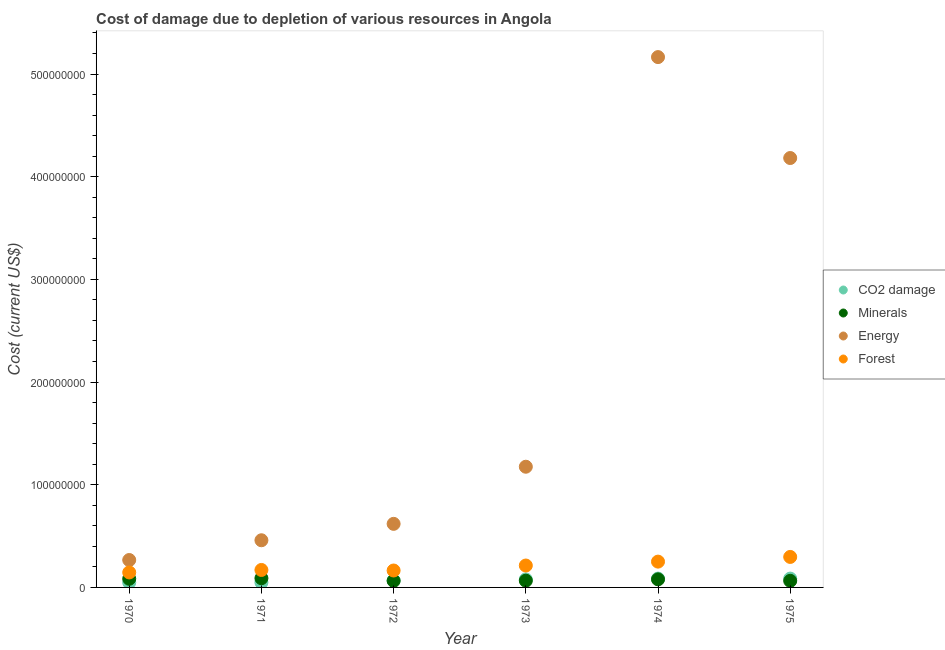What is the cost of damage due to depletion of coal in 1975?
Give a very brief answer. 8.60e+06. Across all years, what is the maximum cost of damage due to depletion of coal?
Offer a terse response. 8.60e+06. Across all years, what is the minimum cost of damage due to depletion of minerals?
Give a very brief answer. 6.41e+06. In which year was the cost of damage due to depletion of energy maximum?
Your response must be concise. 1974. What is the total cost of damage due to depletion of coal in the graph?
Your response must be concise. 4.14e+07. What is the difference between the cost of damage due to depletion of forests in 1971 and that in 1975?
Give a very brief answer. -1.27e+07. What is the difference between the cost of damage due to depletion of minerals in 1972 and the cost of damage due to depletion of coal in 1971?
Ensure brevity in your answer.  1.59e+06. What is the average cost of damage due to depletion of minerals per year?
Your response must be concise. 7.45e+06. In the year 1973, what is the difference between the cost of damage due to depletion of minerals and cost of damage due to depletion of forests?
Offer a terse response. -1.48e+07. What is the ratio of the cost of damage due to depletion of forests in 1973 to that in 1974?
Make the answer very short. 0.85. What is the difference between the highest and the second highest cost of damage due to depletion of coal?
Provide a succinct answer. 1.27e+04. What is the difference between the highest and the lowest cost of damage due to depletion of forests?
Your answer should be very brief. 1.51e+07. In how many years, is the cost of damage due to depletion of energy greater than the average cost of damage due to depletion of energy taken over all years?
Offer a very short reply. 2. Is the sum of the cost of damage due to depletion of forests in 1972 and 1974 greater than the maximum cost of damage due to depletion of coal across all years?
Keep it short and to the point. Yes. Is it the case that in every year, the sum of the cost of damage due to depletion of energy and cost of damage due to depletion of forests is greater than the sum of cost of damage due to depletion of minerals and cost of damage due to depletion of coal?
Your answer should be compact. Yes. Is the cost of damage due to depletion of minerals strictly less than the cost of damage due to depletion of coal over the years?
Your answer should be compact. No. How many dotlines are there?
Your response must be concise. 4. Are the values on the major ticks of Y-axis written in scientific E-notation?
Make the answer very short. No. Does the graph contain any zero values?
Keep it short and to the point. No. Does the graph contain grids?
Offer a terse response. No. Where does the legend appear in the graph?
Offer a terse response. Center right. How many legend labels are there?
Keep it short and to the point. 4. How are the legend labels stacked?
Offer a terse response. Vertical. What is the title of the graph?
Make the answer very short. Cost of damage due to depletion of various resources in Angola . Does "Other expenses" appear as one of the legend labels in the graph?
Ensure brevity in your answer.  No. What is the label or title of the Y-axis?
Your response must be concise. Cost (current US$). What is the Cost (current US$) of CO2 damage in 1970?
Your answer should be compact. 4.78e+06. What is the Cost (current US$) in Minerals in 1970?
Provide a short and direct response. 8.42e+06. What is the Cost (current US$) of Energy in 1970?
Offer a terse response. 2.67e+07. What is the Cost (current US$) in Forest in 1970?
Provide a succinct answer. 1.46e+07. What is the Cost (current US$) in CO2 damage in 1971?
Offer a very short reply. 4.84e+06. What is the Cost (current US$) of Minerals in 1971?
Provide a succinct answer. 8.98e+06. What is the Cost (current US$) in Energy in 1971?
Provide a short and direct response. 4.59e+07. What is the Cost (current US$) of Forest in 1971?
Ensure brevity in your answer.  1.70e+07. What is the Cost (current US$) in CO2 damage in 1972?
Offer a very short reply. 6.75e+06. What is the Cost (current US$) in Minerals in 1972?
Offer a very short reply. 6.43e+06. What is the Cost (current US$) in Energy in 1972?
Ensure brevity in your answer.  6.19e+07. What is the Cost (current US$) in Forest in 1972?
Offer a very short reply. 1.65e+07. What is the Cost (current US$) in CO2 damage in 1973?
Keep it short and to the point. 7.80e+06. What is the Cost (current US$) in Minerals in 1973?
Your answer should be compact. 6.57e+06. What is the Cost (current US$) in Energy in 1973?
Offer a very short reply. 1.18e+08. What is the Cost (current US$) of Forest in 1973?
Provide a succinct answer. 2.13e+07. What is the Cost (current US$) of CO2 damage in 1974?
Keep it short and to the point. 8.59e+06. What is the Cost (current US$) in Minerals in 1974?
Provide a short and direct response. 7.87e+06. What is the Cost (current US$) in Energy in 1974?
Make the answer very short. 5.16e+08. What is the Cost (current US$) in Forest in 1974?
Keep it short and to the point. 2.51e+07. What is the Cost (current US$) of CO2 damage in 1975?
Give a very brief answer. 8.60e+06. What is the Cost (current US$) in Minerals in 1975?
Provide a short and direct response. 6.41e+06. What is the Cost (current US$) of Energy in 1975?
Your response must be concise. 4.18e+08. What is the Cost (current US$) in Forest in 1975?
Provide a short and direct response. 2.97e+07. Across all years, what is the maximum Cost (current US$) of CO2 damage?
Give a very brief answer. 8.60e+06. Across all years, what is the maximum Cost (current US$) of Minerals?
Offer a terse response. 8.98e+06. Across all years, what is the maximum Cost (current US$) in Energy?
Provide a short and direct response. 5.16e+08. Across all years, what is the maximum Cost (current US$) of Forest?
Offer a very short reply. 2.97e+07. Across all years, what is the minimum Cost (current US$) of CO2 damage?
Ensure brevity in your answer.  4.78e+06. Across all years, what is the minimum Cost (current US$) in Minerals?
Your answer should be compact. 6.41e+06. Across all years, what is the minimum Cost (current US$) of Energy?
Your answer should be compact. 2.67e+07. Across all years, what is the minimum Cost (current US$) in Forest?
Offer a very short reply. 1.46e+07. What is the total Cost (current US$) of CO2 damage in the graph?
Provide a short and direct response. 4.14e+07. What is the total Cost (current US$) of Minerals in the graph?
Keep it short and to the point. 4.47e+07. What is the total Cost (current US$) in Energy in the graph?
Your answer should be compact. 1.19e+09. What is the total Cost (current US$) of Forest in the graph?
Make the answer very short. 1.24e+08. What is the difference between the Cost (current US$) in CO2 damage in 1970 and that in 1971?
Offer a terse response. -5.73e+04. What is the difference between the Cost (current US$) of Minerals in 1970 and that in 1971?
Your answer should be compact. -5.59e+05. What is the difference between the Cost (current US$) of Energy in 1970 and that in 1971?
Make the answer very short. -1.92e+07. What is the difference between the Cost (current US$) of Forest in 1970 and that in 1971?
Your response must be concise. -2.42e+06. What is the difference between the Cost (current US$) of CO2 damage in 1970 and that in 1972?
Make the answer very short. -1.97e+06. What is the difference between the Cost (current US$) of Minerals in 1970 and that in 1972?
Your answer should be compact. 1.99e+06. What is the difference between the Cost (current US$) in Energy in 1970 and that in 1972?
Keep it short and to the point. -3.52e+07. What is the difference between the Cost (current US$) in Forest in 1970 and that in 1972?
Give a very brief answer. -1.89e+06. What is the difference between the Cost (current US$) of CO2 damage in 1970 and that in 1973?
Make the answer very short. -3.02e+06. What is the difference between the Cost (current US$) in Minerals in 1970 and that in 1973?
Your answer should be very brief. 1.85e+06. What is the difference between the Cost (current US$) of Energy in 1970 and that in 1973?
Your response must be concise. -9.08e+07. What is the difference between the Cost (current US$) in Forest in 1970 and that in 1973?
Provide a short and direct response. -6.74e+06. What is the difference between the Cost (current US$) in CO2 damage in 1970 and that in 1974?
Provide a short and direct response. -3.80e+06. What is the difference between the Cost (current US$) in Minerals in 1970 and that in 1974?
Your answer should be compact. 5.56e+05. What is the difference between the Cost (current US$) of Energy in 1970 and that in 1974?
Provide a short and direct response. -4.90e+08. What is the difference between the Cost (current US$) of Forest in 1970 and that in 1974?
Your response must be concise. -1.05e+07. What is the difference between the Cost (current US$) in CO2 damage in 1970 and that in 1975?
Your answer should be compact. -3.82e+06. What is the difference between the Cost (current US$) in Minerals in 1970 and that in 1975?
Offer a very short reply. 2.01e+06. What is the difference between the Cost (current US$) of Energy in 1970 and that in 1975?
Your answer should be compact. -3.91e+08. What is the difference between the Cost (current US$) in Forest in 1970 and that in 1975?
Provide a short and direct response. -1.51e+07. What is the difference between the Cost (current US$) of CO2 damage in 1971 and that in 1972?
Offer a very short reply. -1.91e+06. What is the difference between the Cost (current US$) in Minerals in 1971 and that in 1972?
Your answer should be very brief. 2.55e+06. What is the difference between the Cost (current US$) in Energy in 1971 and that in 1972?
Provide a succinct answer. -1.60e+07. What is the difference between the Cost (current US$) in Forest in 1971 and that in 1972?
Offer a very short reply. 5.24e+05. What is the difference between the Cost (current US$) in CO2 damage in 1971 and that in 1973?
Give a very brief answer. -2.96e+06. What is the difference between the Cost (current US$) in Minerals in 1971 and that in 1973?
Provide a short and direct response. 2.41e+06. What is the difference between the Cost (current US$) of Energy in 1971 and that in 1973?
Make the answer very short. -7.16e+07. What is the difference between the Cost (current US$) in Forest in 1971 and that in 1973?
Give a very brief answer. -4.33e+06. What is the difference between the Cost (current US$) in CO2 damage in 1971 and that in 1974?
Offer a very short reply. -3.75e+06. What is the difference between the Cost (current US$) in Minerals in 1971 and that in 1974?
Make the answer very short. 1.12e+06. What is the difference between the Cost (current US$) in Energy in 1971 and that in 1974?
Ensure brevity in your answer.  -4.71e+08. What is the difference between the Cost (current US$) of Forest in 1971 and that in 1974?
Your answer should be very brief. -8.12e+06. What is the difference between the Cost (current US$) of CO2 damage in 1971 and that in 1975?
Give a very brief answer. -3.76e+06. What is the difference between the Cost (current US$) of Minerals in 1971 and that in 1975?
Your answer should be very brief. 2.57e+06. What is the difference between the Cost (current US$) in Energy in 1971 and that in 1975?
Offer a terse response. -3.72e+08. What is the difference between the Cost (current US$) of Forest in 1971 and that in 1975?
Ensure brevity in your answer.  -1.27e+07. What is the difference between the Cost (current US$) in CO2 damage in 1972 and that in 1973?
Keep it short and to the point. -1.05e+06. What is the difference between the Cost (current US$) of Minerals in 1972 and that in 1973?
Make the answer very short. -1.45e+05. What is the difference between the Cost (current US$) of Energy in 1972 and that in 1973?
Your answer should be compact. -5.56e+07. What is the difference between the Cost (current US$) in Forest in 1972 and that in 1973?
Your answer should be compact. -4.85e+06. What is the difference between the Cost (current US$) in CO2 damage in 1972 and that in 1974?
Ensure brevity in your answer.  -1.84e+06. What is the difference between the Cost (current US$) in Minerals in 1972 and that in 1974?
Your answer should be very brief. -1.44e+06. What is the difference between the Cost (current US$) of Energy in 1972 and that in 1974?
Your answer should be very brief. -4.55e+08. What is the difference between the Cost (current US$) of Forest in 1972 and that in 1974?
Keep it short and to the point. -8.65e+06. What is the difference between the Cost (current US$) of CO2 damage in 1972 and that in 1975?
Your response must be concise. -1.85e+06. What is the difference between the Cost (current US$) in Minerals in 1972 and that in 1975?
Your answer should be compact. 1.51e+04. What is the difference between the Cost (current US$) of Energy in 1972 and that in 1975?
Ensure brevity in your answer.  -3.56e+08. What is the difference between the Cost (current US$) in Forest in 1972 and that in 1975?
Your answer should be very brief. -1.32e+07. What is the difference between the Cost (current US$) in CO2 damage in 1973 and that in 1974?
Your response must be concise. -7.88e+05. What is the difference between the Cost (current US$) of Minerals in 1973 and that in 1974?
Your answer should be very brief. -1.29e+06. What is the difference between the Cost (current US$) of Energy in 1973 and that in 1974?
Give a very brief answer. -3.99e+08. What is the difference between the Cost (current US$) in Forest in 1973 and that in 1974?
Keep it short and to the point. -3.80e+06. What is the difference between the Cost (current US$) of CO2 damage in 1973 and that in 1975?
Make the answer very short. -8.00e+05. What is the difference between the Cost (current US$) of Minerals in 1973 and that in 1975?
Your response must be concise. 1.60e+05. What is the difference between the Cost (current US$) of Energy in 1973 and that in 1975?
Your answer should be very brief. -3.01e+08. What is the difference between the Cost (current US$) in Forest in 1973 and that in 1975?
Provide a succinct answer. -8.37e+06. What is the difference between the Cost (current US$) of CO2 damage in 1974 and that in 1975?
Make the answer very short. -1.27e+04. What is the difference between the Cost (current US$) in Minerals in 1974 and that in 1975?
Offer a terse response. 1.45e+06. What is the difference between the Cost (current US$) of Energy in 1974 and that in 1975?
Your answer should be very brief. 9.83e+07. What is the difference between the Cost (current US$) in Forest in 1974 and that in 1975?
Provide a short and direct response. -4.57e+06. What is the difference between the Cost (current US$) of CO2 damage in 1970 and the Cost (current US$) of Minerals in 1971?
Give a very brief answer. -4.20e+06. What is the difference between the Cost (current US$) of CO2 damage in 1970 and the Cost (current US$) of Energy in 1971?
Give a very brief answer. -4.11e+07. What is the difference between the Cost (current US$) in CO2 damage in 1970 and the Cost (current US$) in Forest in 1971?
Make the answer very short. -1.22e+07. What is the difference between the Cost (current US$) in Minerals in 1970 and the Cost (current US$) in Energy in 1971?
Make the answer very short. -3.75e+07. What is the difference between the Cost (current US$) of Minerals in 1970 and the Cost (current US$) of Forest in 1971?
Give a very brief answer. -8.58e+06. What is the difference between the Cost (current US$) in Energy in 1970 and the Cost (current US$) in Forest in 1971?
Keep it short and to the point. 9.69e+06. What is the difference between the Cost (current US$) of CO2 damage in 1970 and the Cost (current US$) of Minerals in 1972?
Your response must be concise. -1.65e+06. What is the difference between the Cost (current US$) in CO2 damage in 1970 and the Cost (current US$) in Energy in 1972?
Provide a succinct answer. -5.71e+07. What is the difference between the Cost (current US$) in CO2 damage in 1970 and the Cost (current US$) in Forest in 1972?
Your response must be concise. -1.17e+07. What is the difference between the Cost (current US$) in Minerals in 1970 and the Cost (current US$) in Energy in 1972?
Provide a succinct answer. -5.35e+07. What is the difference between the Cost (current US$) of Minerals in 1970 and the Cost (current US$) of Forest in 1972?
Ensure brevity in your answer.  -8.06e+06. What is the difference between the Cost (current US$) of Energy in 1970 and the Cost (current US$) of Forest in 1972?
Your answer should be compact. 1.02e+07. What is the difference between the Cost (current US$) in CO2 damage in 1970 and the Cost (current US$) in Minerals in 1973?
Offer a terse response. -1.79e+06. What is the difference between the Cost (current US$) of CO2 damage in 1970 and the Cost (current US$) of Energy in 1973?
Give a very brief answer. -1.13e+08. What is the difference between the Cost (current US$) of CO2 damage in 1970 and the Cost (current US$) of Forest in 1973?
Keep it short and to the point. -1.65e+07. What is the difference between the Cost (current US$) of Minerals in 1970 and the Cost (current US$) of Energy in 1973?
Give a very brief answer. -1.09e+08. What is the difference between the Cost (current US$) in Minerals in 1970 and the Cost (current US$) in Forest in 1973?
Ensure brevity in your answer.  -1.29e+07. What is the difference between the Cost (current US$) of Energy in 1970 and the Cost (current US$) of Forest in 1973?
Provide a succinct answer. 5.37e+06. What is the difference between the Cost (current US$) of CO2 damage in 1970 and the Cost (current US$) of Minerals in 1974?
Provide a succinct answer. -3.08e+06. What is the difference between the Cost (current US$) of CO2 damage in 1970 and the Cost (current US$) of Energy in 1974?
Provide a succinct answer. -5.12e+08. What is the difference between the Cost (current US$) of CO2 damage in 1970 and the Cost (current US$) of Forest in 1974?
Give a very brief answer. -2.03e+07. What is the difference between the Cost (current US$) in Minerals in 1970 and the Cost (current US$) in Energy in 1974?
Offer a terse response. -5.08e+08. What is the difference between the Cost (current US$) of Minerals in 1970 and the Cost (current US$) of Forest in 1974?
Offer a very short reply. -1.67e+07. What is the difference between the Cost (current US$) in Energy in 1970 and the Cost (current US$) in Forest in 1974?
Provide a succinct answer. 1.57e+06. What is the difference between the Cost (current US$) of CO2 damage in 1970 and the Cost (current US$) of Minerals in 1975?
Your answer should be very brief. -1.63e+06. What is the difference between the Cost (current US$) of CO2 damage in 1970 and the Cost (current US$) of Energy in 1975?
Your answer should be compact. -4.13e+08. What is the difference between the Cost (current US$) of CO2 damage in 1970 and the Cost (current US$) of Forest in 1975?
Your response must be concise. -2.49e+07. What is the difference between the Cost (current US$) in Minerals in 1970 and the Cost (current US$) in Energy in 1975?
Offer a terse response. -4.10e+08. What is the difference between the Cost (current US$) of Minerals in 1970 and the Cost (current US$) of Forest in 1975?
Provide a short and direct response. -2.13e+07. What is the difference between the Cost (current US$) of Energy in 1970 and the Cost (current US$) of Forest in 1975?
Your answer should be very brief. -3.01e+06. What is the difference between the Cost (current US$) in CO2 damage in 1971 and the Cost (current US$) in Minerals in 1972?
Make the answer very short. -1.59e+06. What is the difference between the Cost (current US$) of CO2 damage in 1971 and the Cost (current US$) of Energy in 1972?
Your response must be concise. -5.71e+07. What is the difference between the Cost (current US$) in CO2 damage in 1971 and the Cost (current US$) in Forest in 1972?
Your answer should be compact. -1.16e+07. What is the difference between the Cost (current US$) of Minerals in 1971 and the Cost (current US$) of Energy in 1972?
Offer a terse response. -5.29e+07. What is the difference between the Cost (current US$) of Minerals in 1971 and the Cost (current US$) of Forest in 1972?
Your answer should be compact. -7.50e+06. What is the difference between the Cost (current US$) in Energy in 1971 and the Cost (current US$) in Forest in 1972?
Provide a short and direct response. 2.94e+07. What is the difference between the Cost (current US$) of CO2 damage in 1971 and the Cost (current US$) of Minerals in 1973?
Give a very brief answer. -1.74e+06. What is the difference between the Cost (current US$) of CO2 damage in 1971 and the Cost (current US$) of Energy in 1973?
Provide a short and direct response. -1.13e+08. What is the difference between the Cost (current US$) of CO2 damage in 1971 and the Cost (current US$) of Forest in 1973?
Your response must be concise. -1.65e+07. What is the difference between the Cost (current US$) in Minerals in 1971 and the Cost (current US$) in Energy in 1973?
Provide a short and direct response. -1.09e+08. What is the difference between the Cost (current US$) in Minerals in 1971 and the Cost (current US$) in Forest in 1973?
Make the answer very short. -1.23e+07. What is the difference between the Cost (current US$) of Energy in 1971 and the Cost (current US$) of Forest in 1973?
Keep it short and to the point. 2.46e+07. What is the difference between the Cost (current US$) in CO2 damage in 1971 and the Cost (current US$) in Minerals in 1974?
Provide a short and direct response. -3.03e+06. What is the difference between the Cost (current US$) in CO2 damage in 1971 and the Cost (current US$) in Energy in 1974?
Provide a succinct answer. -5.12e+08. What is the difference between the Cost (current US$) in CO2 damage in 1971 and the Cost (current US$) in Forest in 1974?
Provide a succinct answer. -2.03e+07. What is the difference between the Cost (current US$) of Minerals in 1971 and the Cost (current US$) of Energy in 1974?
Ensure brevity in your answer.  -5.07e+08. What is the difference between the Cost (current US$) in Minerals in 1971 and the Cost (current US$) in Forest in 1974?
Make the answer very short. -1.61e+07. What is the difference between the Cost (current US$) in Energy in 1971 and the Cost (current US$) in Forest in 1974?
Make the answer very short. 2.08e+07. What is the difference between the Cost (current US$) of CO2 damage in 1971 and the Cost (current US$) of Minerals in 1975?
Provide a short and direct response. -1.57e+06. What is the difference between the Cost (current US$) of CO2 damage in 1971 and the Cost (current US$) of Energy in 1975?
Ensure brevity in your answer.  -4.13e+08. What is the difference between the Cost (current US$) of CO2 damage in 1971 and the Cost (current US$) of Forest in 1975?
Offer a very short reply. -2.49e+07. What is the difference between the Cost (current US$) in Minerals in 1971 and the Cost (current US$) in Energy in 1975?
Ensure brevity in your answer.  -4.09e+08. What is the difference between the Cost (current US$) of Minerals in 1971 and the Cost (current US$) of Forest in 1975?
Provide a succinct answer. -2.07e+07. What is the difference between the Cost (current US$) of Energy in 1971 and the Cost (current US$) of Forest in 1975?
Make the answer very short. 1.62e+07. What is the difference between the Cost (current US$) of CO2 damage in 1972 and the Cost (current US$) of Minerals in 1973?
Provide a succinct answer. 1.76e+05. What is the difference between the Cost (current US$) of CO2 damage in 1972 and the Cost (current US$) of Energy in 1973?
Your answer should be very brief. -1.11e+08. What is the difference between the Cost (current US$) of CO2 damage in 1972 and the Cost (current US$) of Forest in 1973?
Give a very brief answer. -1.46e+07. What is the difference between the Cost (current US$) of Minerals in 1972 and the Cost (current US$) of Energy in 1973?
Make the answer very short. -1.11e+08. What is the difference between the Cost (current US$) of Minerals in 1972 and the Cost (current US$) of Forest in 1973?
Keep it short and to the point. -1.49e+07. What is the difference between the Cost (current US$) in Energy in 1972 and the Cost (current US$) in Forest in 1973?
Your answer should be very brief. 4.06e+07. What is the difference between the Cost (current US$) of CO2 damage in 1972 and the Cost (current US$) of Minerals in 1974?
Provide a short and direct response. -1.11e+06. What is the difference between the Cost (current US$) of CO2 damage in 1972 and the Cost (current US$) of Energy in 1974?
Offer a very short reply. -5.10e+08. What is the difference between the Cost (current US$) in CO2 damage in 1972 and the Cost (current US$) in Forest in 1974?
Your answer should be compact. -1.84e+07. What is the difference between the Cost (current US$) in Minerals in 1972 and the Cost (current US$) in Energy in 1974?
Make the answer very short. -5.10e+08. What is the difference between the Cost (current US$) of Minerals in 1972 and the Cost (current US$) of Forest in 1974?
Provide a succinct answer. -1.87e+07. What is the difference between the Cost (current US$) of Energy in 1972 and the Cost (current US$) of Forest in 1974?
Provide a short and direct response. 3.68e+07. What is the difference between the Cost (current US$) in CO2 damage in 1972 and the Cost (current US$) in Minerals in 1975?
Offer a terse response. 3.36e+05. What is the difference between the Cost (current US$) in CO2 damage in 1972 and the Cost (current US$) in Energy in 1975?
Your answer should be compact. -4.11e+08. What is the difference between the Cost (current US$) in CO2 damage in 1972 and the Cost (current US$) in Forest in 1975?
Your answer should be compact. -2.30e+07. What is the difference between the Cost (current US$) of Minerals in 1972 and the Cost (current US$) of Energy in 1975?
Offer a very short reply. -4.12e+08. What is the difference between the Cost (current US$) in Minerals in 1972 and the Cost (current US$) in Forest in 1975?
Ensure brevity in your answer.  -2.33e+07. What is the difference between the Cost (current US$) of Energy in 1972 and the Cost (current US$) of Forest in 1975?
Provide a succinct answer. 3.22e+07. What is the difference between the Cost (current US$) of CO2 damage in 1973 and the Cost (current US$) of Minerals in 1974?
Give a very brief answer. -6.62e+04. What is the difference between the Cost (current US$) in CO2 damage in 1973 and the Cost (current US$) in Energy in 1974?
Give a very brief answer. -5.09e+08. What is the difference between the Cost (current US$) in CO2 damage in 1973 and the Cost (current US$) in Forest in 1974?
Keep it short and to the point. -1.73e+07. What is the difference between the Cost (current US$) in Minerals in 1973 and the Cost (current US$) in Energy in 1974?
Make the answer very short. -5.10e+08. What is the difference between the Cost (current US$) of Minerals in 1973 and the Cost (current US$) of Forest in 1974?
Offer a terse response. -1.86e+07. What is the difference between the Cost (current US$) of Energy in 1973 and the Cost (current US$) of Forest in 1974?
Keep it short and to the point. 9.24e+07. What is the difference between the Cost (current US$) of CO2 damage in 1973 and the Cost (current US$) of Minerals in 1975?
Make the answer very short. 1.39e+06. What is the difference between the Cost (current US$) in CO2 damage in 1973 and the Cost (current US$) in Energy in 1975?
Give a very brief answer. -4.10e+08. What is the difference between the Cost (current US$) in CO2 damage in 1973 and the Cost (current US$) in Forest in 1975?
Your answer should be compact. -2.19e+07. What is the difference between the Cost (current US$) in Minerals in 1973 and the Cost (current US$) in Energy in 1975?
Make the answer very short. -4.12e+08. What is the difference between the Cost (current US$) of Minerals in 1973 and the Cost (current US$) of Forest in 1975?
Offer a terse response. -2.31e+07. What is the difference between the Cost (current US$) of Energy in 1973 and the Cost (current US$) of Forest in 1975?
Your response must be concise. 8.78e+07. What is the difference between the Cost (current US$) in CO2 damage in 1974 and the Cost (current US$) in Minerals in 1975?
Your response must be concise. 2.17e+06. What is the difference between the Cost (current US$) of CO2 damage in 1974 and the Cost (current US$) of Energy in 1975?
Provide a short and direct response. -4.10e+08. What is the difference between the Cost (current US$) of CO2 damage in 1974 and the Cost (current US$) of Forest in 1975?
Make the answer very short. -2.11e+07. What is the difference between the Cost (current US$) in Minerals in 1974 and the Cost (current US$) in Energy in 1975?
Offer a terse response. -4.10e+08. What is the difference between the Cost (current US$) in Minerals in 1974 and the Cost (current US$) in Forest in 1975?
Give a very brief answer. -2.18e+07. What is the difference between the Cost (current US$) of Energy in 1974 and the Cost (current US$) of Forest in 1975?
Your response must be concise. 4.87e+08. What is the average Cost (current US$) in CO2 damage per year?
Offer a very short reply. 6.89e+06. What is the average Cost (current US$) in Minerals per year?
Make the answer very short. 7.45e+06. What is the average Cost (current US$) of Energy per year?
Your response must be concise. 1.98e+08. What is the average Cost (current US$) of Forest per year?
Ensure brevity in your answer.  2.07e+07. In the year 1970, what is the difference between the Cost (current US$) of CO2 damage and Cost (current US$) of Minerals?
Ensure brevity in your answer.  -3.64e+06. In the year 1970, what is the difference between the Cost (current US$) in CO2 damage and Cost (current US$) in Energy?
Give a very brief answer. -2.19e+07. In the year 1970, what is the difference between the Cost (current US$) of CO2 damage and Cost (current US$) of Forest?
Provide a short and direct response. -9.80e+06. In the year 1970, what is the difference between the Cost (current US$) of Minerals and Cost (current US$) of Energy?
Provide a short and direct response. -1.83e+07. In the year 1970, what is the difference between the Cost (current US$) of Minerals and Cost (current US$) of Forest?
Make the answer very short. -6.16e+06. In the year 1970, what is the difference between the Cost (current US$) in Energy and Cost (current US$) in Forest?
Give a very brief answer. 1.21e+07. In the year 1971, what is the difference between the Cost (current US$) of CO2 damage and Cost (current US$) of Minerals?
Make the answer very short. -4.14e+06. In the year 1971, what is the difference between the Cost (current US$) in CO2 damage and Cost (current US$) in Energy?
Provide a succinct answer. -4.11e+07. In the year 1971, what is the difference between the Cost (current US$) of CO2 damage and Cost (current US$) of Forest?
Your answer should be very brief. -1.22e+07. In the year 1971, what is the difference between the Cost (current US$) in Minerals and Cost (current US$) in Energy?
Your answer should be very brief. -3.69e+07. In the year 1971, what is the difference between the Cost (current US$) of Minerals and Cost (current US$) of Forest?
Ensure brevity in your answer.  -8.02e+06. In the year 1971, what is the difference between the Cost (current US$) in Energy and Cost (current US$) in Forest?
Your answer should be compact. 2.89e+07. In the year 1972, what is the difference between the Cost (current US$) of CO2 damage and Cost (current US$) of Minerals?
Make the answer very short. 3.21e+05. In the year 1972, what is the difference between the Cost (current US$) in CO2 damage and Cost (current US$) in Energy?
Make the answer very short. -5.52e+07. In the year 1972, what is the difference between the Cost (current US$) in CO2 damage and Cost (current US$) in Forest?
Provide a short and direct response. -9.73e+06. In the year 1972, what is the difference between the Cost (current US$) in Minerals and Cost (current US$) in Energy?
Provide a succinct answer. -5.55e+07. In the year 1972, what is the difference between the Cost (current US$) of Minerals and Cost (current US$) of Forest?
Your response must be concise. -1.01e+07. In the year 1972, what is the difference between the Cost (current US$) in Energy and Cost (current US$) in Forest?
Your answer should be compact. 4.54e+07. In the year 1973, what is the difference between the Cost (current US$) of CO2 damage and Cost (current US$) of Minerals?
Provide a short and direct response. 1.22e+06. In the year 1973, what is the difference between the Cost (current US$) of CO2 damage and Cost (current US$) of Energy?
Give a very brief answer. -1.10e+08. In the year 1973, what is the difference between the Cost (current US$) in CO2 damage and Cost (current US$) in Forest?
Offer a very short reply. -1.35e+07. In the year 1973, what is the difference between the Cost (current US$) in Minerals and Cost (current US$) in Energy?
Provide a succinct answer. -1.11e+08. In the year 1973, what is the difference between the Cost (current US$) in Minerals and Cost (current US$) in Forest?
Provide a succinct answer. -1.48e+07. In the year 1973, what is the difference between the Cost (current US$) of Energy and Cost (current US$) of Forest?
Your answer should be very brief. 9.62e+07. In the year 1974, what is the difference between the Cost (current US$) of CO2 damage and Cost (current US$) of Minerals?
Your answer should be very brief. 7.21e+05. In the year 1974, what is the difference between the Cost (current US$) of CO2 damage and Cost (current US$) of Energy?
Provide a succinct answer. -5.08e+08. In the year 1974, what is the difference between the Cost (current US$) in CO2 damage and Cost (current US$) in Forest?
Give a very brief answer. -1.65e+07. In the year 1974, what is the difference between the Cost (current US$) of Minerals and Cost (current US$) of Energy?
Provide a short and direct response. -5.09e+08. In the year 1974, what is the difference between the Cost (current US$) in Minerals and Cost (current US$) in Forest?
Offer a very short reply. -1.73e+07. In the year 1974, what is the difference between the Cost (current US$) of Energy and Cost (current US$) of Forest?
Make the answer very short. 4.91e+08. In the year 1975, what is the difference between the Cost (current US$) in CO2 damage and Cost (current US$) in Minerals?
Offer a terse response. 2.19e+06. In the year 1975, what is the difference between the Cost (current US$) in CO2 damage and Cost (current US$) in Energy?
Your answer should be compact. -4.10e+08. In the year 1975, what is the difference between the Cost (current US$) of CO2 damage and Cost (current US$) of Forest?
Your response must be concise. -2.11e+07. In the year 1975, what is the difference between the Cost (current US$) in Minerals and Cost (current US$) in Energy?
Make the answer very short. -4.12e+08. In the year 1975, what is the difference between the Cost (current US$) of Minerals and Cost (current US$) of Forest?
Ensure brevity in your answer.  -2.33e+07. In the year 1975, what is the difference between the Cost (current US$) of Energy and Cost (current US$) of Forest?
Offer a terse response. 3.88e+08. What is the ratio of the Cost (current US$) of CO2 damage in 1970 to that in 1971?
Your response must be concise. 0.99. What is the ratio of the Cost (current US$) of Minerals in 1970 to that in 1971?
Your response must be concise. 0.94. What is the ratio of the Cost (current US$) of Energy in 1970 to that in 1971?
Your answer should be very brief. 0.58. What is the ratio of the Cost (current US$) in Forest in 1970 to that in 1971?
Your answer should be compact. 0.86. What is the ratio of the Cost (current US$) in CO2 damage in 1970 to that in 1972?
Your answer should be very brief. 0.71. What is the ratio of the Cost (current US$) of Minerals in 1970 to that in 1972?
Your answer should be very brief. 1.31. What is the ratio of the Cost (current US$) in Energy in 1970 to that in 1972?
Your answer should be very brief. 0.43. What is the ratio of the Cost (current US$) of Forest in 1970 to that in 1972?
Make the answer very short. 0.89. What is the ratio of the Cost (current US$) in CO2 damage in 1970 to that in 1973?
Offer a terse response. 0.61. What is the ratio of the Cost (current US$) in Minerals in 1970 to that in 1973?
Your response must be concise. 1.28. What is the ratio of the Cost (current US$) in Energy in 1970 to that in 1973?
Offer a terse response. 0.23. What is the ratio of the Cost (current US$) of Forest in 1970 to that in 1973?
Provide a short and direct response. 0.68. What is the ratio of the Cost (current US$) in CO2 damage in 1970 to that in 1974?
Provide a succinct answer. 0.56. What is the ratio of the Cost (current US$) in Minerals in 1970 to that in 1974?
Ensure brevity in your answer.  1.07. What is the ratio of the Cost (current US$) of Energy in 1970 to that in 1974?
Ensure brevity in your answer.  0.05. What is the ratio of the Cost (current US$) in Forest in 1970 to that in 1974?
Your response must be concise. 0.58. What is the ratio of the Cost (current US$) of CO2 damage in 1970 to that in 1975?
Keep it short and to the point. 0.56. What is the ratio of the Cost (current US$) of Minerals in 1970 to that in 1975?
Offer a terse response. 1.31. What is the ratio of the Cost (current US$) in Energy in 1970 to that in 1975?
Your response must be concise. 0.06. What is the ratio of the Cost (current US$) of Forest in 1970 to that in 1975?
Your answer should be very brief. 0.49. What is the ratio of the Cost (current US$) in CO2 damage in 1971 to that in 1972?
Offer a very short reply. 0.72. What is the ratio of the Cost (current US$) of Minerals in 1971 to that in 1972?
Give a very brief answer. 1.4. What is the ratio of the Cost (current US$) in Energy in 1971 to that in 1972?
Your response must be concise. 0.74. What is the ratio of the Cost (current US$) of Forest in 1971 to that in 1972?
Offer a terse response. 1.03. What is the ratio of the Cost (current US$) in CO2 damage in 1971 to that in 1973?
Make the answer very short. 0.62. What is the ratio of the Cost (current US$) in Minerals in 1971 to that in 1973?
Ensure brevity in your answer.  1.37. What is the ratio of the Cost (current US$) in Energy in 1971 to that in 1973?
Provide a short and direct response. 0.39. What is the ratio of the Cost (current US$) in Forest in 1971 to that in 1973?
Your response must be concise. 0.8. What is the ratio of the Cost (current US$) in CO2 damage in 1971 to that in 1974?
Keep it short and to the point. 0.56. What is the ratio of the Cost (current US$) of Minerals in 1971 to that in 1974?
Your answer should be compact. 1.14. What is the ratio of the Cost (current US$) in Energy in 1971 to that in 1974?
Your response must be concise. 0.09. What is the ratio of the Cost (current US$) in Forest in 1971 to that in 1974?
Offer a terse response. 0.68. What is the ratio of the Cost (current US$) of CO2 damage in 1971 to that in 1975?
Offer a terse response. 0.56. What is the ratio of the Cost (current US$) of Minerals in 1971 to that in 1975?
Offer a terse response. 1.4. What is the ratio of the Cost (current US$) of Energy in 1971 to that in 1975?
Your answer should be very brief. 0.11. What is the ratio of the Cost (current US$) in Forest in 1971 to that in 1975?
Your response must be concise. 0.57. What is the ratio of the Cost (current US$) in CO2 damage in 1972 to that in 1973?
Provide a short and direct response. 0.87. What is the ratio of the Cost (current US$) in Minerals in 1972 to that in 1973?
Your answer should be very brief. 0.98. What is the ratio of the Cost (current US$) of Energy in 1972 to that in 1973?
Ensure brevity in your answer.  0.53. What is the ratio of the Cost (current US$) of Forest in 1972 to that in 1973?
Your response must be concise. 0.77. What is the ratio of the Cost (current US$) in CO2 damage in 1972 to that in 1974?
Your answer should be compact. 0.79. What is the ratio of the Cost (current US$) of Minerals in 1972 to that in 1974?
Offer a very short reply. 0.82. What is the ratio of the Cost (current US$) of Energy in 1972 to that in 1974?
Give a very brief answer. 0.12. What is the ratio of the Cost (current US$) in Forest in 1972 to that in 1974?
Your response must be concise. 0.66. What is the ratio of the Cost (current US$) of CO2 damage in 1972 to that in 1975?
Your response must be concise. 0.79. What is the ratio of the Cost (current US$) in Minerals in 1972 to that in 1975?
Ensure brevity in your answer.  1. What is the ratio of the Cost (current US$) in Energy in 1972 to that in 1975?
Make the answer very short. 0.15. What is the ratio of the Cost (current US$) of Forest in 1972 to that in 1975?
Your answer should be compact. 0.55. What is the ratio of the Cost (current US$) in CO2 damage in 1973 to that in 1974?
Offer a terse response. 0.91. What is the ratio of the Cost (current US$) in Minerals in 1973 to that in 1974?
Your answer should be compact. 0.84. What is the ratio of the Cost (current US$) of Energy in 1973 to that in 1974?
Your answer should be very brief. 0.23. What is the ratio of the Cost (current US$) in Forest in 1973 to that in 1974?
Your response must be concise. 0.85. What is the ratio of the Cost (current US$) of CO2 damage in 1973 to that in 1975?
Provide a short and direct response. 0.91. What is the ratio of the Cost (current US$) of Energy in 1973 to that in 1975?
Provide a short and direct response. 0.28. What is the ratio of the Cost (current US$) of Forest in 1973 to that in 1975?
Make the answer very short. 0.72. What is the ratio of the Cost (current US$) in CO2 damage in 1974 to that in 1975?
Your answer should be compact. 1. What is the ratio of the Cost (current US$) in Minerals in 1974 to that in 1975?
Provide a short and direct response. 1.23. What is the ratio of the Cost (current US$) in Energy in 1974 to that in 1975?
Keep it short and to the point. 1.24. What is the ratio of the Cost (current US$) in Forest in 1974 to that in 1975?
Keep it short and to the point. 0.85. What is the difference between the highest and the second highest Cost (current US$) in CO2 damage?
Your answer should be very brief. 1.27e+04. What is the difference between the highest and the second highest Cost (current US$) in Minerals?
Offer a terse response. 5.59e+05. What is the difference between the highest and the second highest Cost (current US$) of Energy?
Provide a succinct answer. 9.83e+07. What is the difference between the highest and the second highest Cost (current US$) in Forest?
Offer a very short reply. 4.57e+06. What is the difference between the highest and the lowest Cost (current US$) of CO2 damage?
Your answer should be very brief. 3.82e+06. What is the difference between the highest and the lowest Cost (current US$) in Minerals?
Provide a succinct answer. 2.57e+06. What is the difference between the highest and the lowest Cost (current US$) in Energy?
Offer a very short reply. 4.90e+08. What is the difference between the highest and the lowest Cost (current US$) of Forest?
Give a very brief answer. 1.51e+07. 